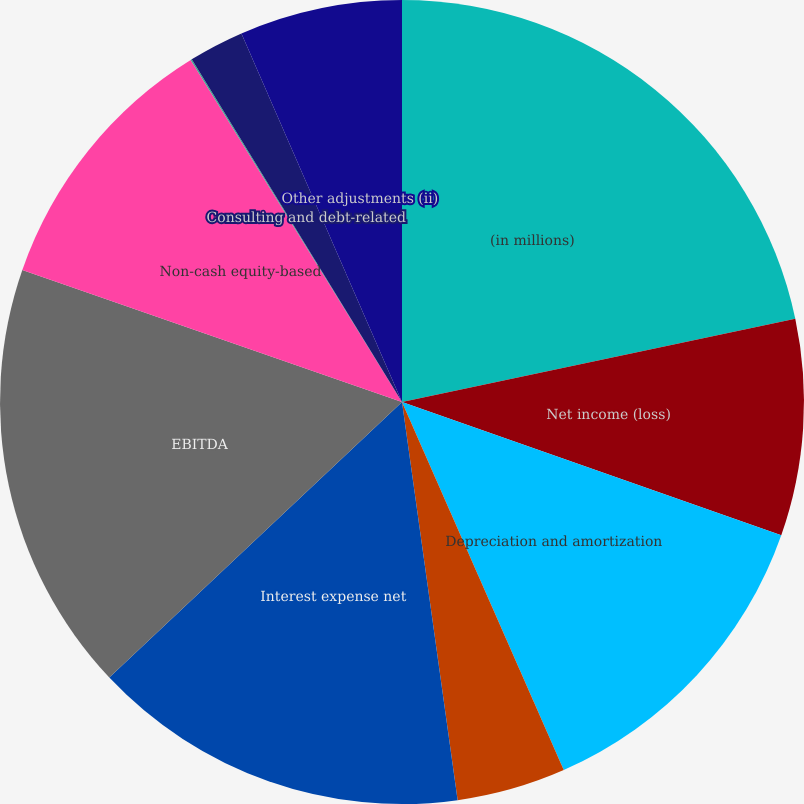Convert chart to OTSL. <chart><loc_0><loc_0><loc_500><loc_500><pie_chart><fcel>(in millions)<fcel>Net income (loss)<fcel>Depreciation and amortization<fcel>Income tax expense (benefit)<fcel>Interest expense net<fcel>EBITDA<fcel>Non-cash equity-based<fcel>Sponsor fees<fcel>Consulting and debt-related<fcel>Other adjustments (ii)<nl><fcel>21.68%<fcel>8.7%<fcel>13.03%<fcel>4.38%<fcel>15.19%<fcel>17.35%<fcel>10.86%<fcel>0.05%<fcel>2.22%<fcel>6.54%<nl></chart> 